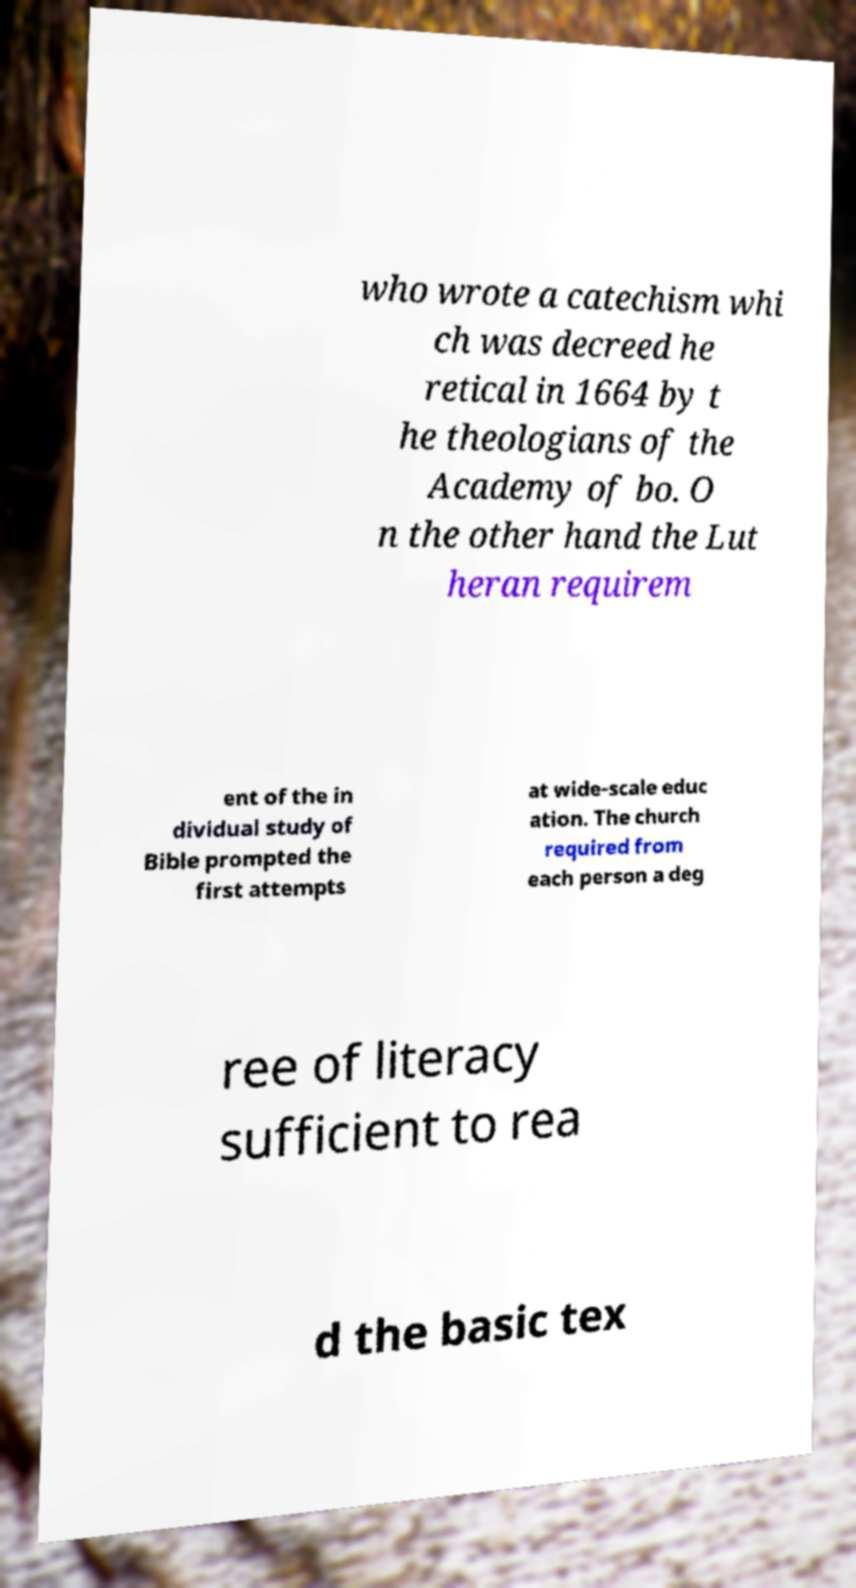Could you assist in decoding the text presented in this image and type it out clearly? who wrote a catechism whi ch was decreed he retical in 1664 by t he theologians of the Academy of bo. O n the other hand the Lut heran requirem ent of the in dividual study of Bible prompted the first attempts at wide-scale educ ation. The church required from each person a deg ree of literacy sufficient to rea d the basic tex 